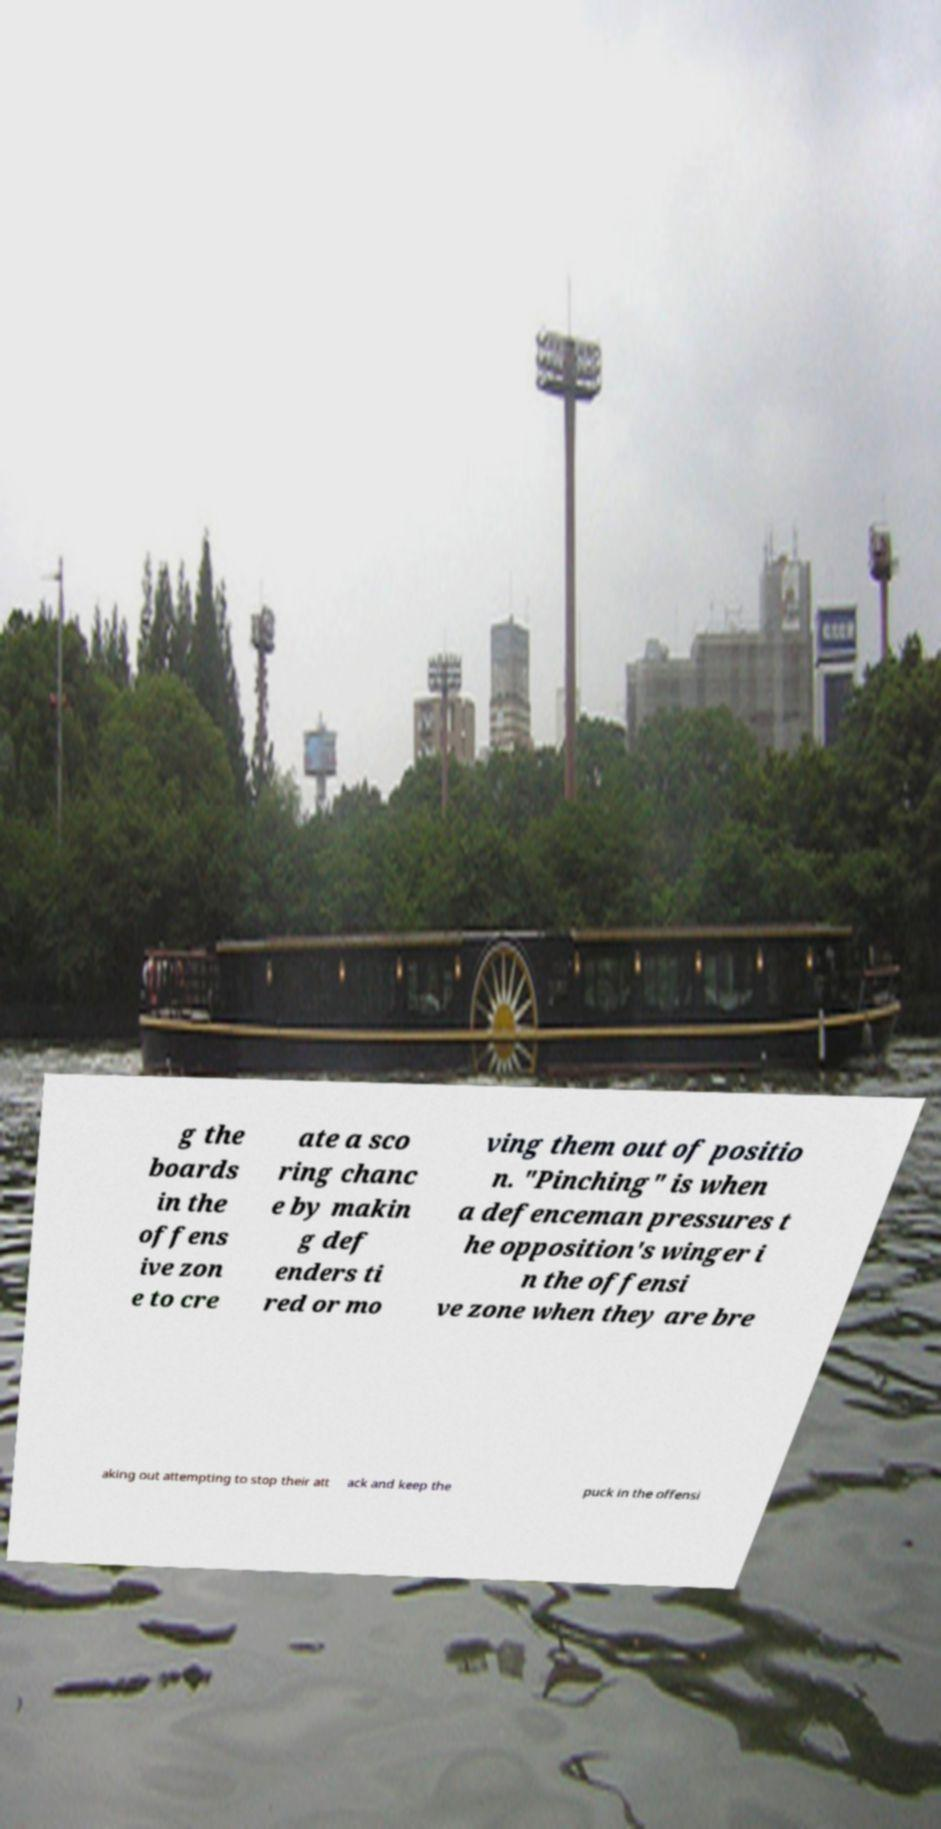What messages or text are displayed in this image? I need them in a readable, typed format. g the boards in the offens ive zon e to cre ate a sco ring chanc e by makin g def enders ti red or mo ving them out of positio n. "Pinching" is when a defenceman pressures t he opposition's winger i n the offensi ve zone when they are bre aking out attempting to stop their att ack and keep the puck in the offensi 